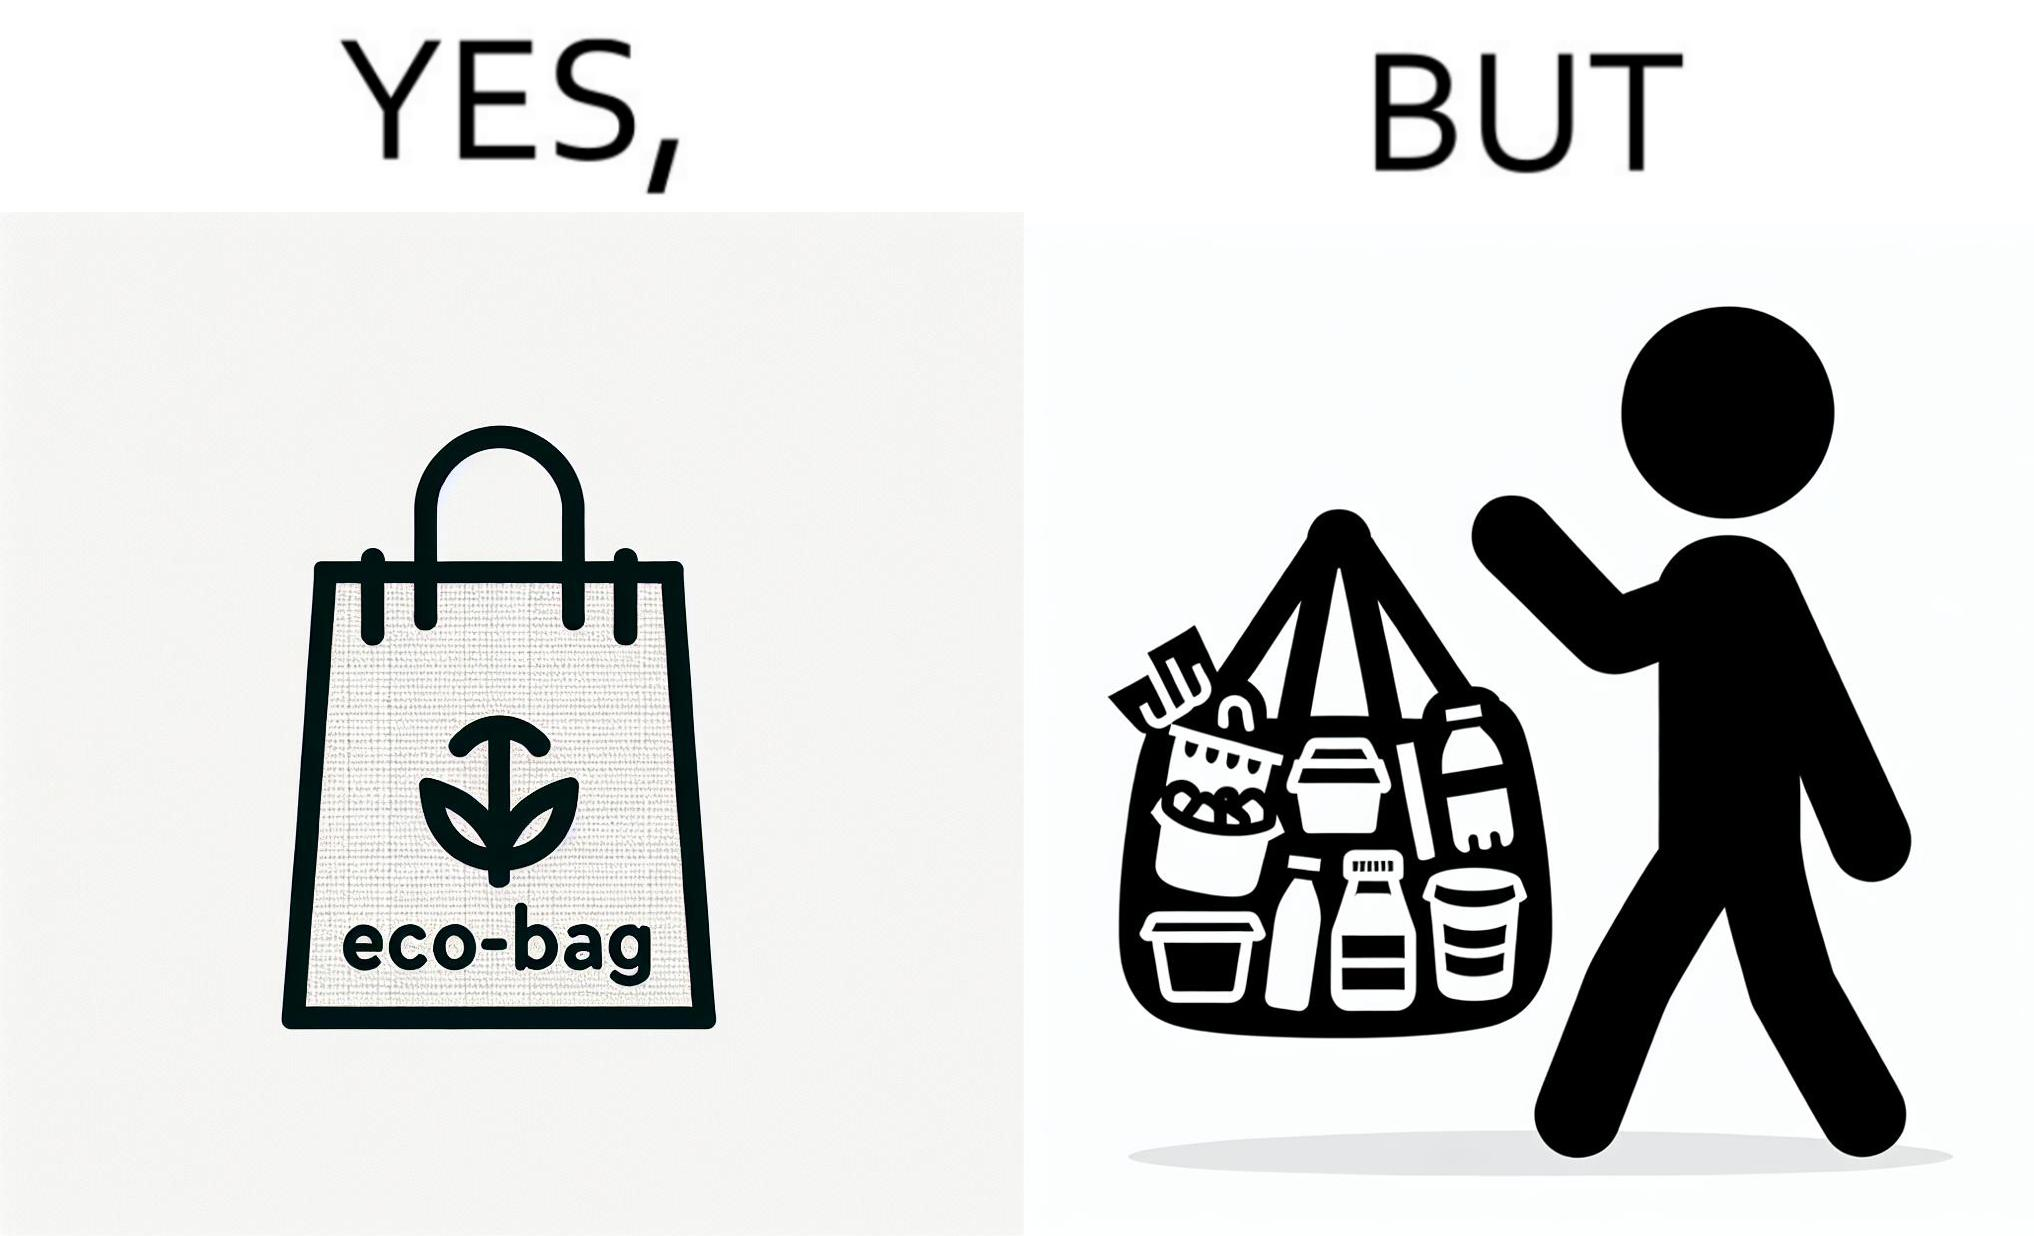Describe the contrast between the left and right parts of this image. In the left part of the image: a bag with text "eco-bag" on it, probably made up of some eco-friendly materials like cotton or jute In the right part of the image: a person carrying different products inside plastic containers or plastic wrapping in a carry bag 